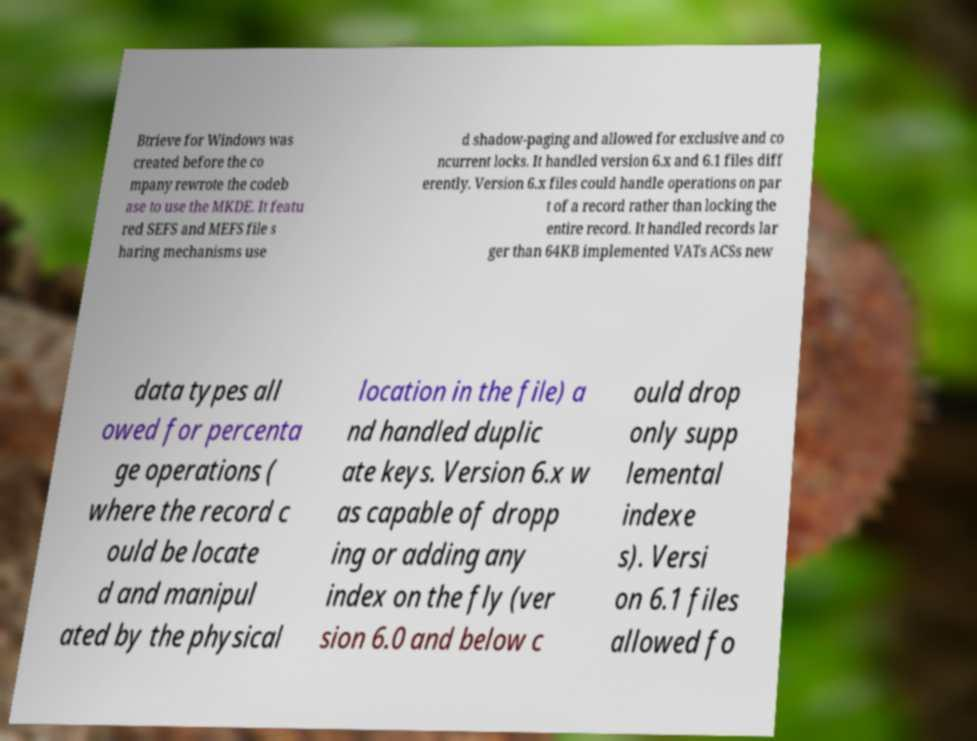Please read and relay the text visible in this image. What does it say? Btrieve for Windows was created before the co mpany rewrote the codeb ase to use the MKDE. It featu red SEFS and MEFS file s haring mechanisms use d shadow-paging and allowed for exclusive and co ncurrent locks. It handled version 6.x and 6.1 files diff erently. Version 6.x files could handle operations on par t of a record rather than locking the entire record. It handled records lar ger than 64KB implemented VATs ACSs new data types all owed for percenta ge operations ( where the record c ould be locate d and manipul ated by the physical location in the file) a nd handled duplic ate keys. Version 6.x w as capable of dropp ing or adding any index on the fly (ver sion 6.0 and below c ould drop only supp lemental indexe s). Versi on 6.1 files allowed fo 